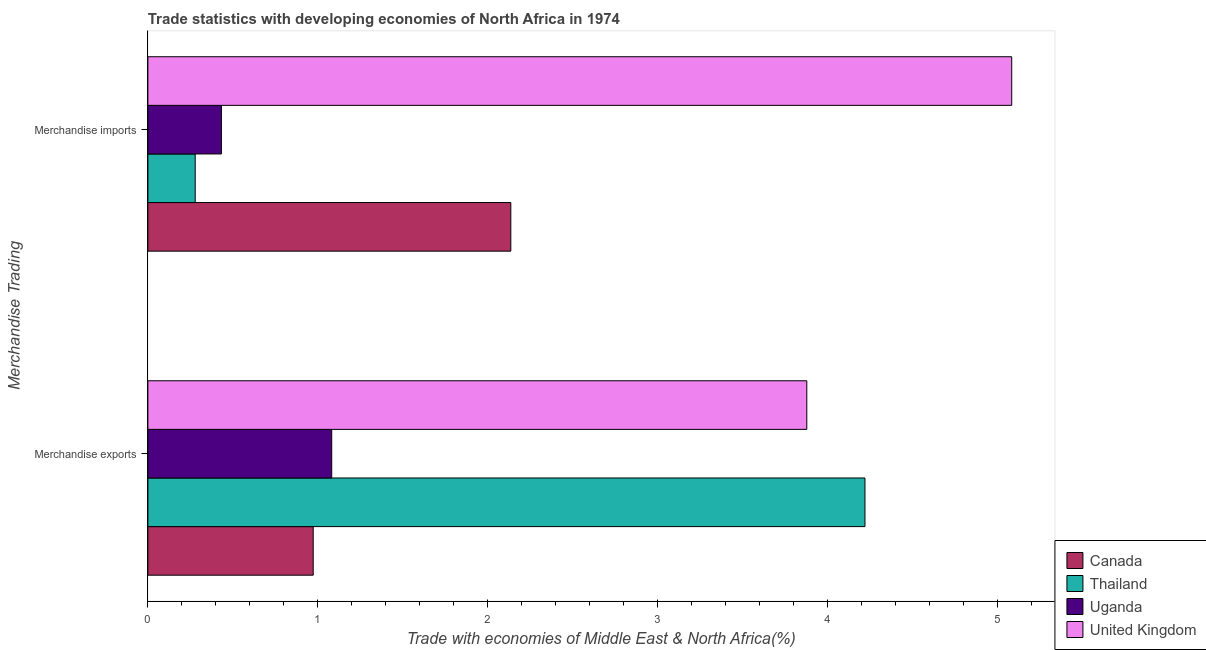How many different coloured bars are there?
Ensure brevity in your answer.  4. What is the label of the 2nd group of bars from the top?
Your answer should be compact. Merchandise exports. What is the merchandise imports in Canada?
Offer a terse response. 2.14. Across all countries, what is the maximum merchandise imports?
Your response must be concise. 5.08. Across all countries, what is the minimum merchandise exports?
Keep it short and to the point. 0.97. In which country was the merchandise imports minimum?
Offer a terse response. Thailand. What is the total merchandise imports in the graph?
Offer a very short reply. 7.93. What is the difference between the merchandise imports in United Kingdom and that in Canada?
Ensure brevity in your answer.  2.95. What is the difference between the merchandise exports in Uganda and the merchandise imports in Canada?
Keep it short and to the point. -1.05. What is the average merchandise exports per country?
Keep it short and to the point. 2.54. What is the difference between the merchandise exports and merchandise imports in Thailand?
Give a very brief answer. 3.94. In how many countries, is the merchandise imports greater than 2 %?
Keep it short and to the point. 2. What is the ratio of the merchandise imports in Canada to that in Uganda?
Provide a succinct answer. 4.94. In how many countries, is the merchandise exports greater than the average merchandise exports taken over all countries?
Your answer should be very brief. 2. How many countries are there in the graph?
Make the answer very short. 4. Does the graph contain any zero values?
Give a very brief answer. No. Does the graph contain grids?
Make the answer very short. No. Where does the legend appear in the graph?
Your response must be concise. Bottom right. How are the legend labels stacked?
Make the answer very short. Vertical. What is the title of the graph?
Give a very brief answer. Trade statistics with developing economies of North Africa in 1974. What is the label or title of the X-axis?
Offer a very short reply. Trade with economies of Middle East & North Africa(%). What is the label or title of the Y-axis?
Offer a very short reply. Merchandise Trading. What is the Trade with economies of Middle East & North Africa(%) in Canada in Merchandise exports?
Give a very brief answer. 0.97. What is the Trade with economies of Middle East & North Africa(%) in Thailand in Merchandise exports?
Provide a short and direct response. 4.22. What is the Trade with economies of Middle East & North Africa(%) of Uganda in Merchandise exports?
Give a very brief answer. 1.08. What is the Trade with economies of Middle East & North Africa(%) of United Kingdom in Merchandise exports?
Make the answer very short. 3.88. What is the Trade with economies of Middle East & North Africa(%) of Canada in Merchandise imports?
Offer a terse response. 2.14. What is the Trade with economies of Middle East & North Africa(%) of Thailand in Merchandise imports?
Offer a very short reply. 0.28. What is the Trade with economies of Middle East & North Africa(%) in Uganda in Merchandise imports?
Make the answer very short. 0.43. What is the Trade with economies of Middle East & North Africa(%) in United Kingdom in Merchandise imports?
Provide a short and direct response. 5.08. Across all Merchandise Trading, what is the maximum Trade with economies of Middle East & North Africa(%) in Canada?
Give a very brief answer. 2.14. Across all Merchandise Trading, what is the maximum Trade with economies of Middle East & North Africa(%) in Thailand?
Your answer should be very brief. 4.22. Across all Merchandise Trading, what is the maximum Trade with economies of Middle East & North Africa(%) in Uganda?
Offer a very short reply. 1.08. Across all Merchandise Trading, what is the maximum Trade with economies of Middle East & North Africa(%) in United Kingdom?
Make the answer very short. 5.08. Across all Merchandise Trading, what is the minimum Trade with economies of Middle East & North Africa(%) in Canada?
Offer a very short reply. 0.97. Across all Merchandise Trading, what is the minimum Trade with economies of Middle East & North Africa(%) in Thailand?
Your response must be concise. 0.28. Across all Merchandise Trading, what is the minimum Trade with economies of Middle East & North Africa(%) of Uganda?
Your answer should be compact. 0.43. Across all Merchandise Trading, what is the minimum Trade with economies of Middle East & North Africa(%) of United Kingdom?
Your response must be concise. 3.88. What is the total Trade with economies of Middle East & North Africa(%) of Canada in the graph?
Your answer should be very brief. 3.11. What is the total Trade with economies of Middle East & North Africa(%) in Thailand in the graph?
Make the answer very short. 4.5. What is the total Trade with economies of Middle East & North Africa(%) of Uganda in the graph?
Your answer should be compact. 1.51. What is the total Trade with economies of Middle East & North Africa(%) in United Kingdom in the graph?
Your response must be concise. 8.96. What is the difference between the Trade with economies of Middle East & North Africa(%) in Canada in Merchandise exports and that in Merchandise imports?
Your response must be concise. -1.16. What is the difference between the Trade with economies of Middle East & North Africa(%) of Thailand in Merchandise exports and that in Merchandise imports?
Provide a succinct answer. 3.94. What is the difference between the Trade with economies of Middle East & North Africa(%) of Uganda in Merchandise exports and that in Merchandise imports?
Your answer should be very brief. 0.65. What is the difference between the Trade with economies of Middle East & North Africa(%) of United Kingdom in Merchandise exports and that in Merchandise imports?
Offer a very short reply. -1.21. What is the difference between the Trade with economies of Middle East & North Africa(%) in Canada in Merchandise exports and the Trade with economies of Middle East & North Africa(%) in Thailand in Merchandise imports?
Your answer should be very brief. 0.69. What is the difference between the Trade with economies of Middle East & North Africa(%) in Canada in Merchandise exports and the Trade with economies of Middle East & North Africa(%) in Uganda in Merchandise imports?
Your answer should be compact. 0.54. What is the difference between the Trade with economies of Middle East & North Africa(%) of Canada in Merchandise exports and the Trade with economies of Middle East & North Africa(%) of United Kingdom in Merchandise imports?
Give a very brief answer. -4.11. What is the difference between the Trade with economies of Middle East & North Africa(%) of Thailand in Merchandise exports and the Trade with economies of Middle East & North Africa(%) of Uganda in Merchandise imports?
Keep it short and to the point. 3.79. What is the difference between the Trade with economies of Middle East & North Africa(%) in Thailand in Merchandise exports and the Trade with economies of Middle East & North Africa(%) in United Kingdom in Merchandise imports?
Ensure brevity in your answer.  -0.86. What is the difference between the Trade with economies of Middle East & North Africa(%) in Uganda in Merchandise exports and the Trade with economies of Middle East & North Africa(%) in United Kingdom in Merchandise imports?
Offer a terse response. -4. What is the average Trade with economies of Middle East & North Africa(%) of Canada per Merchandise Trading?
Your answer should be compact. 1.55. What is the average Trade with economies of Middle East & North Africa(%) of Thailand per Merchandise Trading?
Provide a short and direct response. 2.25. What is the average Trade with economies of Middle East & North Africa(%) of Uganda per Merchandise Trading?
Offer a very short reply. 0.76. What is the average Trade with economies of Middle East & North Africa(%) in United Kingdom per Merchandise Trading?
Give a very brief answer. 4.48. What is the difference between the Trade with economies of Middle East & North Africa(%) in Canada and Trade with economies of Middle East & North Africa(%) in Thailand in Merchandise exports?
Ensure brevity in your answer.  -3.25. What is the difference between the Trade with economies of Middle East & North Africa(%) of Canada and Trade with economies of Middle East & North Africa(%) of Uganda in Merchandise exports?
Make the answer very short. -0.11. What is the difference between the Trade with economies of Middle East & North Africa(%) in Canada and Trade with economies of Middle East & North Africa(%) in United Kingdom in Merchandise exports?
Give a very brief answer. -2.9. What is the difference between the Trade with economies of Middle East & North Africa(%) in Thailand and Trade with economies of Middle East & North Africa(%) in Uganda in Merchandise exports?
Keep it short and to the point. 3.14. What is the difference between the Trade with economies of Middle East & North Africa(%) of Thailand and Trade with economies of Middle East & North Africa(%) of United Kingdom in Merchandise exports?
Ensure brevity in your answer.  0.34. What is the difference between the Trade with economies of Middle East & North Africa(%) in Uganda and Trade with economies of Middle East & North Africa(%) in United Kingdom in Merchandise exports?
Keep it short and to the point. -2.8. What is the difference between the Trade with economies of Middle East & North Africa(%) of Canada and Trade with economies of Middle East & North Africa(%) of Thailand in Merchandise imports?
Your answer should be very brief. 1.86. What is the difference between the Trade with economies of Middle East & North Africa(%) in Canada and Trade with economies of Middle East & North Africa(%) in Uganda in Merchandise imports?
Your response must be concise. 1.7. What is the difference between the Trade with economies of Middle East & North Africa(%) of Canada and Trade with economies of Middle East & North Africa(%) of United Kingdom in Merchandise imports?
Provide a short and direct response. -2.95. What is the difference between the Trade with economies of Middle East & North Africa(%) in Thailand and Trade with economies of Middle East & North Africa(%) in Uganda in Merchandise imports?
Provide a short and direct response. -0.15. What is the difference between the Trade with economies of Middle East & North Africa(%) of Thailand and Trade with economies of Middle East & North Africa(%) of United Kingdom in Merchandise imports?
Your answer should be compact. -4.81. What is the difference between the Trade with economies of Middle East & North Africa(%) of Uganda and Trade with economies of Middle East & North Africa(%) of United Kingdom in Merchandise imports?
Offer a very short reply. -4.65. What is the ratio of the Trade with economies of Middle East & North Africa(%) in Canada in Merchandise exports to that in Merchandise imports?
Provide a short and direct response. 0.46. What is the ratio of the Trade with economies of Middle East & North Africa(%) in Thailand in Merchandise exports to that in Merchandise imports?
Offer a terse response. 15.15. What is the ratio of the Trade with economies of Middle East & North Africa(%) in Uganda in Merchandise exports to that in Merchandise imports?
Offer a very short reply. 2.5. What is the ratio of the Trade with economies of Middle East & North Africa(%) in United Kingdom in Merchandise exports to that in Merchandise imports?
Offer a very short reply. 0.76. What is the difference between the highest and the second highest Trade with economies of Middle East & North Africa(%) in Canada?
Make the answer very short. 1.16. What is the difference between the highest and the second highest Trade with economies of Middle East & North Africa(%) in Thailand?
Provide a succinct answer. 3.94. What is the difference between the highest and the second highest Trade with economies of Middle East & North Africa(%) in Uganda?
Offer a terse response. 0.65. What is the difference between the highest and the second highest Trade with economies of Middle East & North Africa(%) of United Kingdom?
Make the answer very short. 1.21. What is the difference between the highest and the lowest Trade with economies of Middle East & North Africa(%) in Canada?
Make the answer very short. 1.16. What is the difference between the highest and the lowest Trade with economies of Middle East & North Africa(%) in Thailand?
Provide a succinct answer. 3.94. What is the difference between the highest and the lowest Trade with economies of Middle East & North Africa(%) in Uganda?
Your answer should be compact. 0.65. What is the difference between the highest and the lowest Trade with economies of Middle East & North Africa(%) in United Kingdom?
Give a very brief answer. 1.21. 